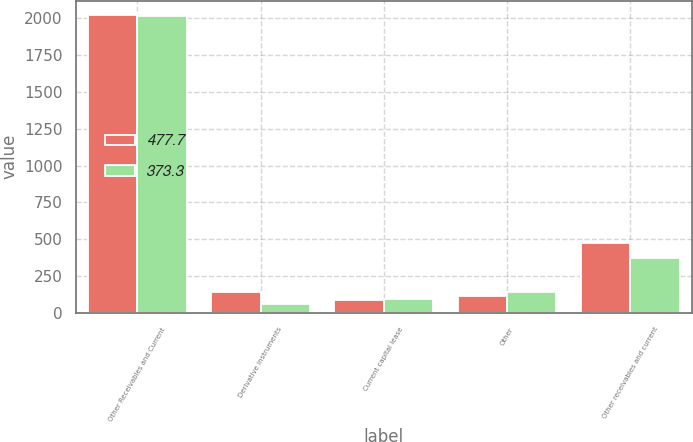<chart> <loc_0><loc_0><loc_500><loc_500><stacked_bar_chart><ecel><fcel>Other Receivables and Current<fcel>Derivative instruments<fcel>Current capital lease<fcel>Other<fcel>Other receivables and current<nl><fcel>477.7<fcel>2019<fcel>142.5<fcel>90.9<fcel>115.5<fcel>477.7<nl><fcel>373.3<fcel>2018<fcel>61.1<fcel>92.1<fcel>142.6<fcel>373.3<nl></chart> 